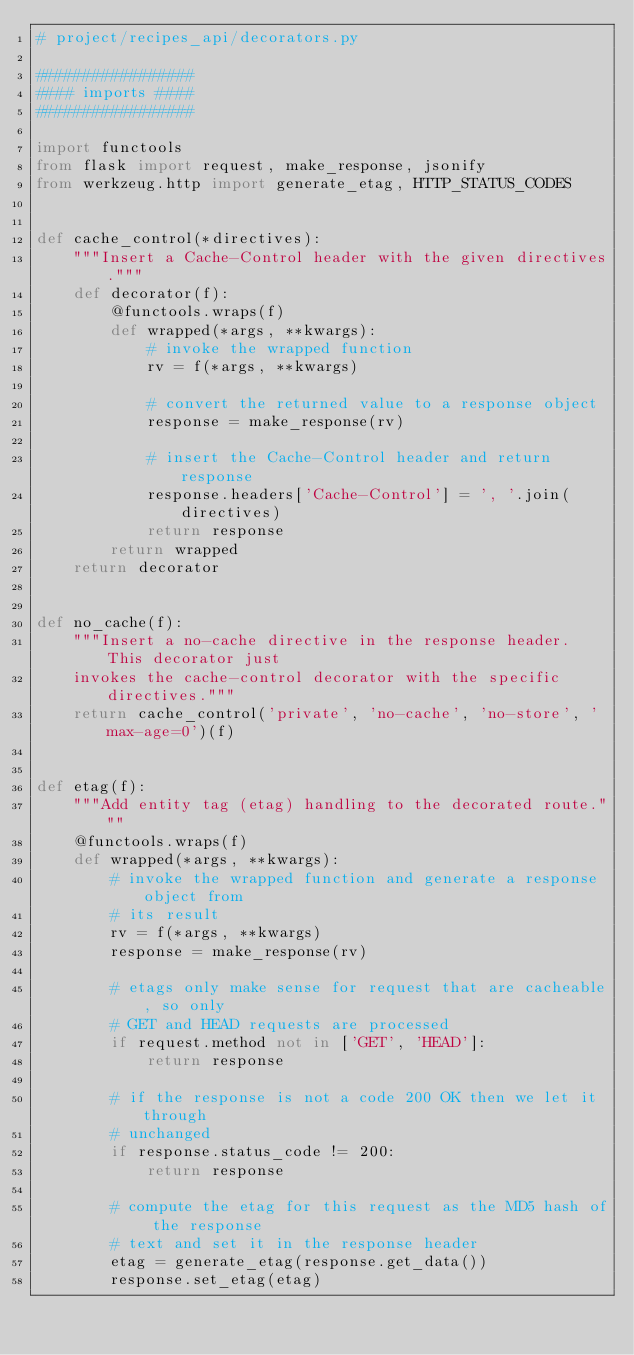<code> <loc_0><loc_0><loc_500><loc_500><_Python_># project/recipes_api/decorators.py

#################
#### imports ####
#################

import functools
from flask import request, make_response, jsonify
from werkzeug.http import generate_etag, HTTP_STATUS_CODES


def cache_control(*directives):
    """Insert a Cache-Control header with the given directives."""
    def decorator(f):
        @functools.wraps(f)
        def wrapped(*args, **kwargs):
            # invoke the wrapped function
            rv = f(*args, **kwargs)

            # convert the returned value to a response object
            response = make_response(rv)

            # insert the Cache-Control header and return response
            response.headers['Cache-Control'] = ', '.join(directives)
            return response
        return wrapped
    return decorator


def no_cache(f):
    """Insert a no-cache directive in the response header. This decorator just
    invokes the cache-control decorator with the specific directives."""
    return cache_control('private', 'no-cache', 'no-store', 'max-age=0')(f)


def etag(f):
    """Add entity tag (etag) handling to the decorated route."""
    @functools.wraps(f)
    def wrapped(*args, **kwargs):
        # invoke the wrapped function and generate a response object from
        # its result
        rv = f(*args, **kwargs)
        response = make_response(rv)

        # etags only make sense for request that are cacheable, so only
        # GET and HEAD requests are processed
        if request.method not in ['GET', 'HEAD']:
            return response

        # if the response is not a code 200 OK then we let it through
        # unchanged
        if response.status_code != 200:
            return response

        # compute the etag for this request as the MD5 hash of the response
        # text and set it in the response header
        etag = generate_etag(response.get_data())
        response.set_etag(etag)
</code> 